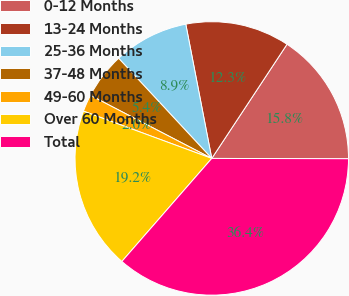Convert chart to OTSL. <chart><loc_0><loc_0><loc_500><loc_500><pie_chart><fcel>0-12 Months<fcel>13-24 Months<fcel>25-36 Months<fcel>37-48 Months<fcel>49-60 Months<fcel>Over 60 Months<fcel>Total<nl><fcel>15.76%<fcel>12.32%<fcel>8.88%<fcel>5.45%<fcel>2.01%<fcel>19.2%<fcel>36.38%<nl></chart> 